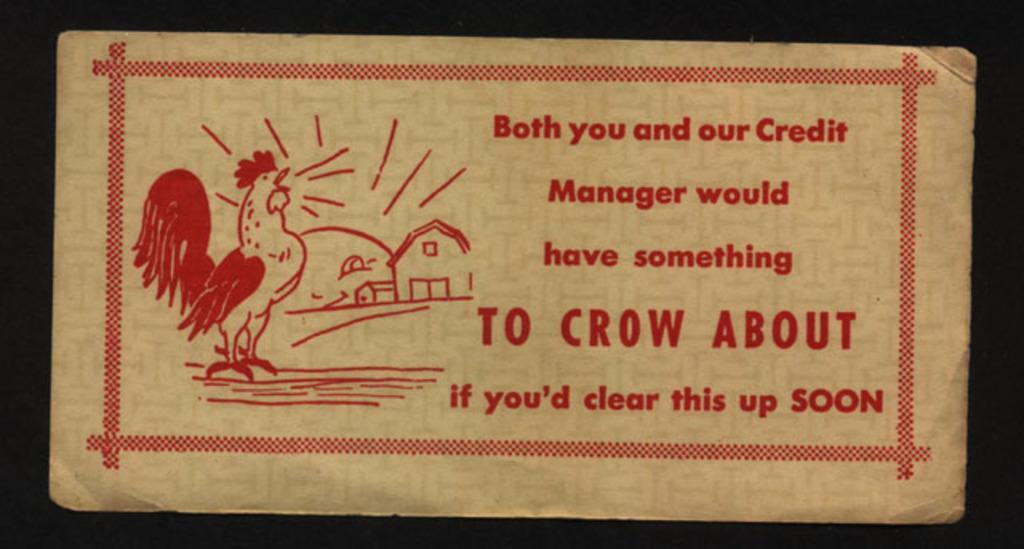Could you give a brief overview of what you see in this image? In this image, we can see a sketch of a hen and some houses and some text on the board and the background is dark. 